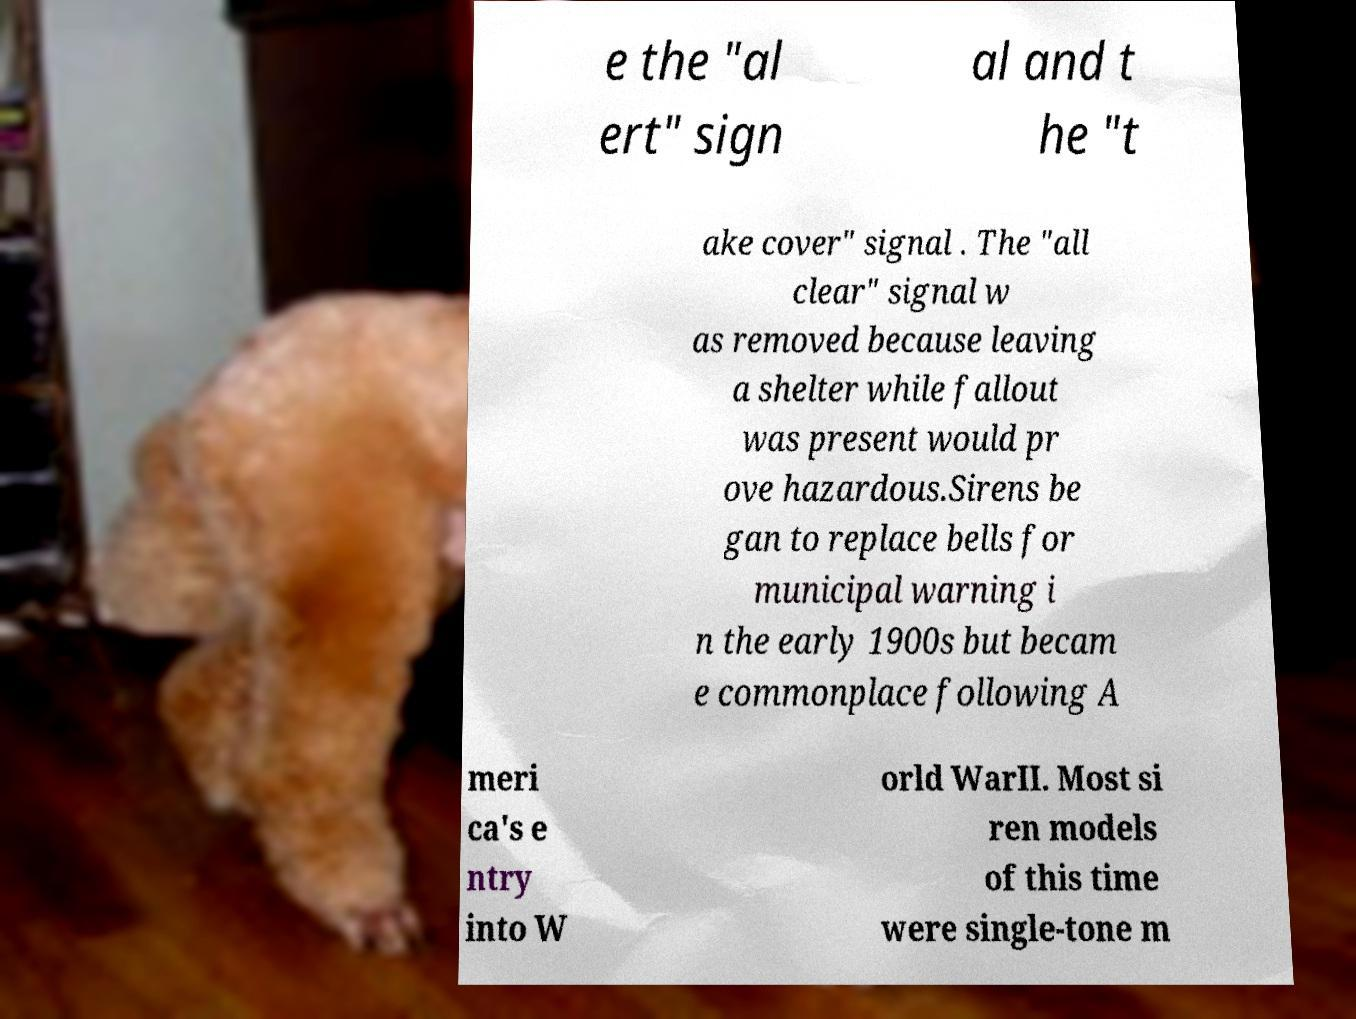Could you extract and type out the text from this image? e the "al ert" sign al and t he "t ake cover" signal . The "all clear" signal w as removed because leaving a shelter while fallout was present would pr ove hazardous.Sirens be gan to replace bells for municipal warning i n the early 1900s but becam e commonplace following A meri ca's e ntry into W orld WarII. Most si ren models of this time were single-tone m 